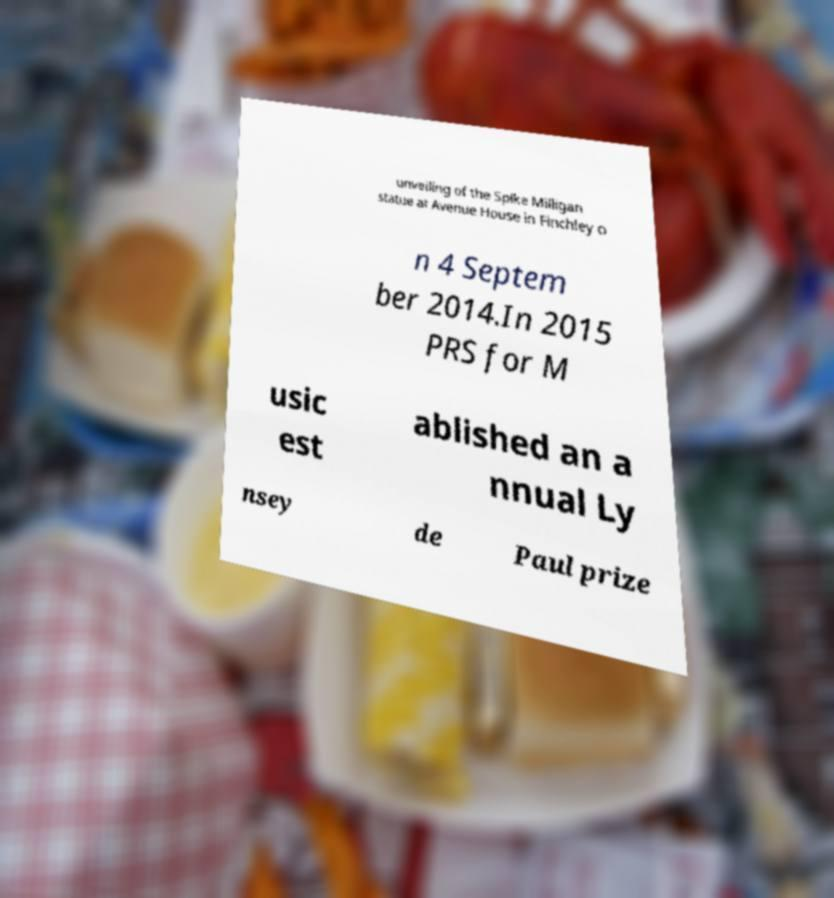Can you read and provide the text displayed in the image?This photo seems to have some interesting text. Can you extract and type it out for me? unveiling of the Spike Milligan statue at Avenue House in Finchley o n 4 Septem ber 2014.In 2015 PRS for M usic est ablished an a nnual Ly nsey de Paul prize 